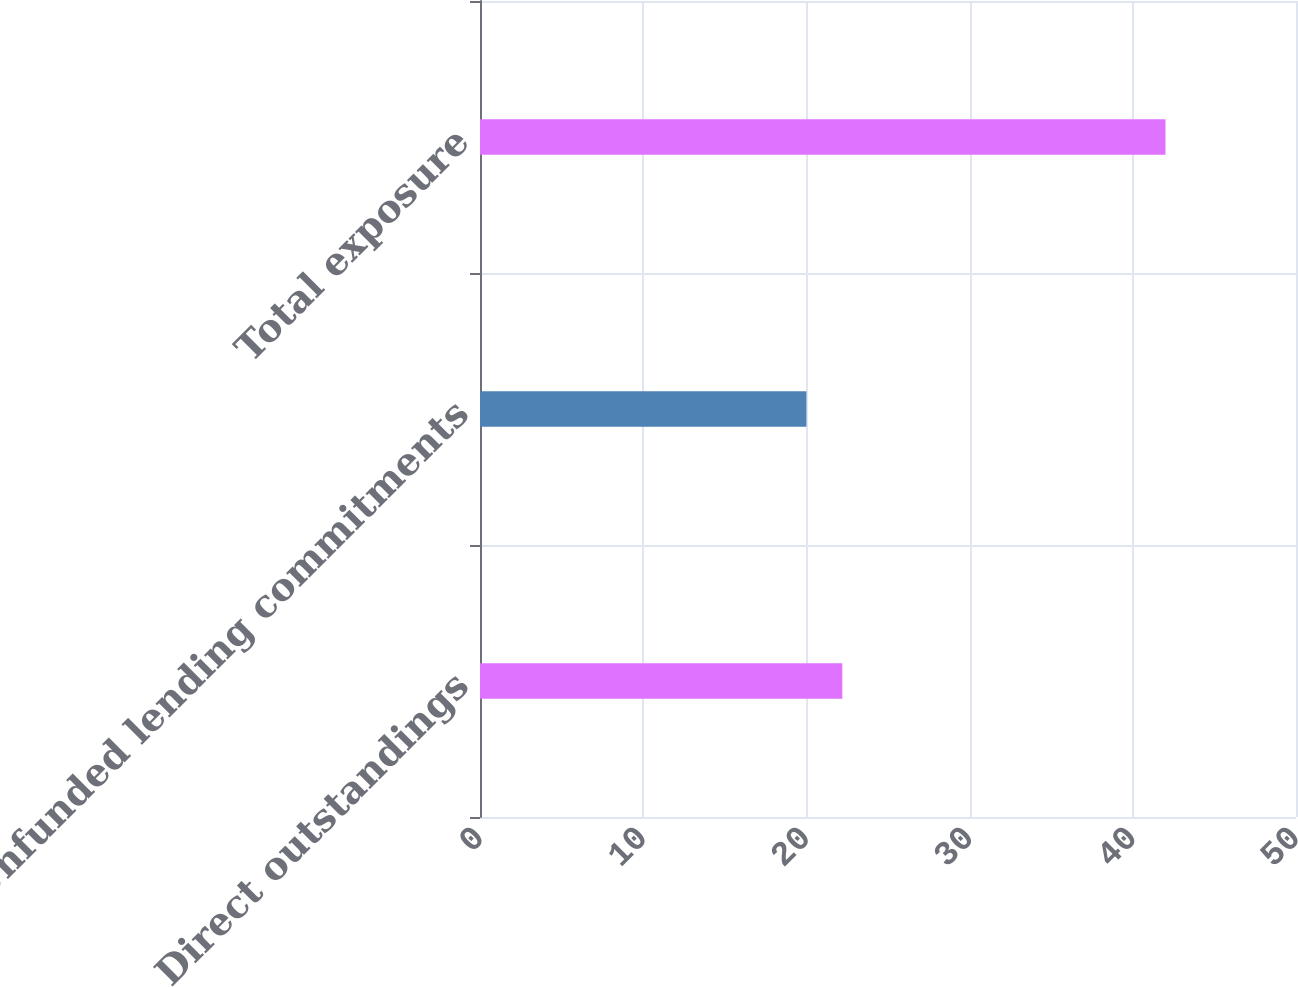Convert chart to OTSL. <chart><loc_0><loc_0><loc_500><loc_500><bar_chart><fcel>Direct outstandings<fcel>Unfunded lending commitments<fcel>Total exposure<nl><fcel>22.2<fcel>20<fcel>42<nl></chart> 